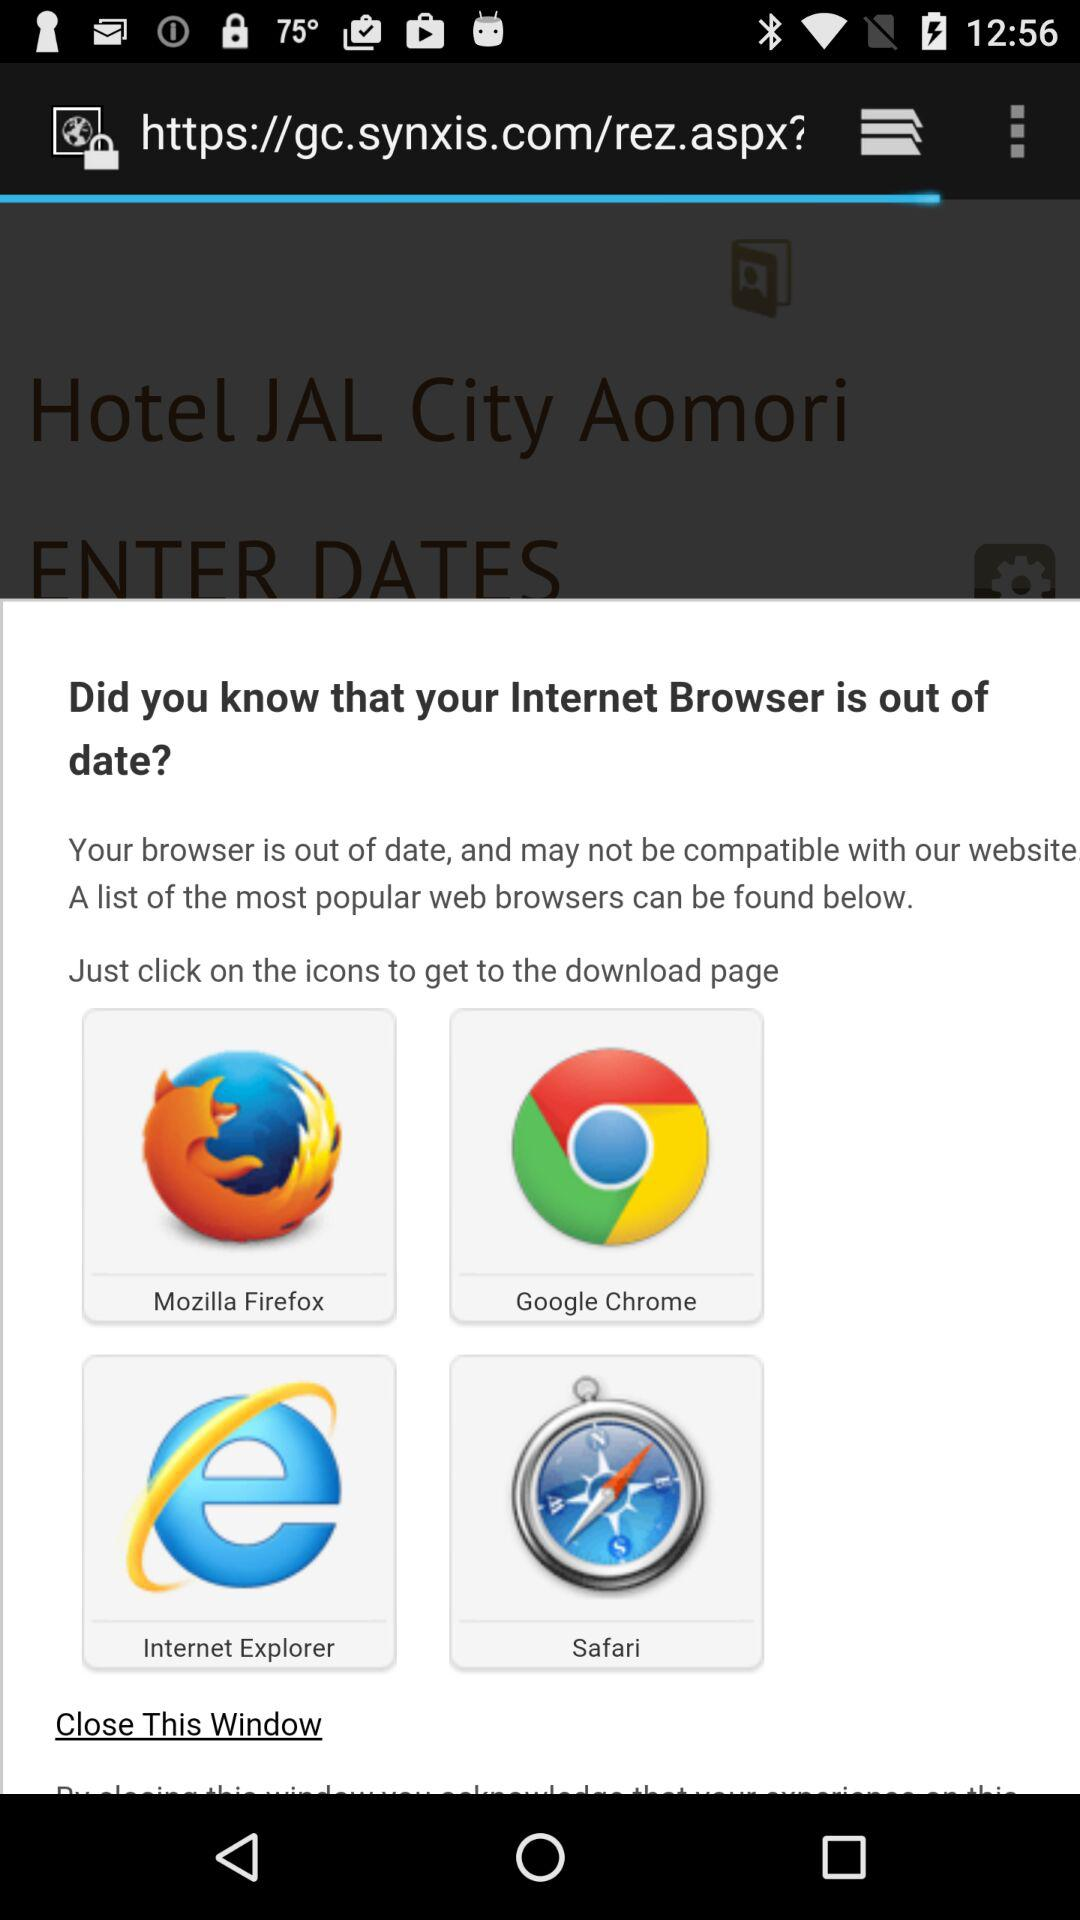What are the names of the web browsers? The names of the web browsers are "Mozilla Firefox", "Google Chrome", "Internet Explorer" and "Safari". 